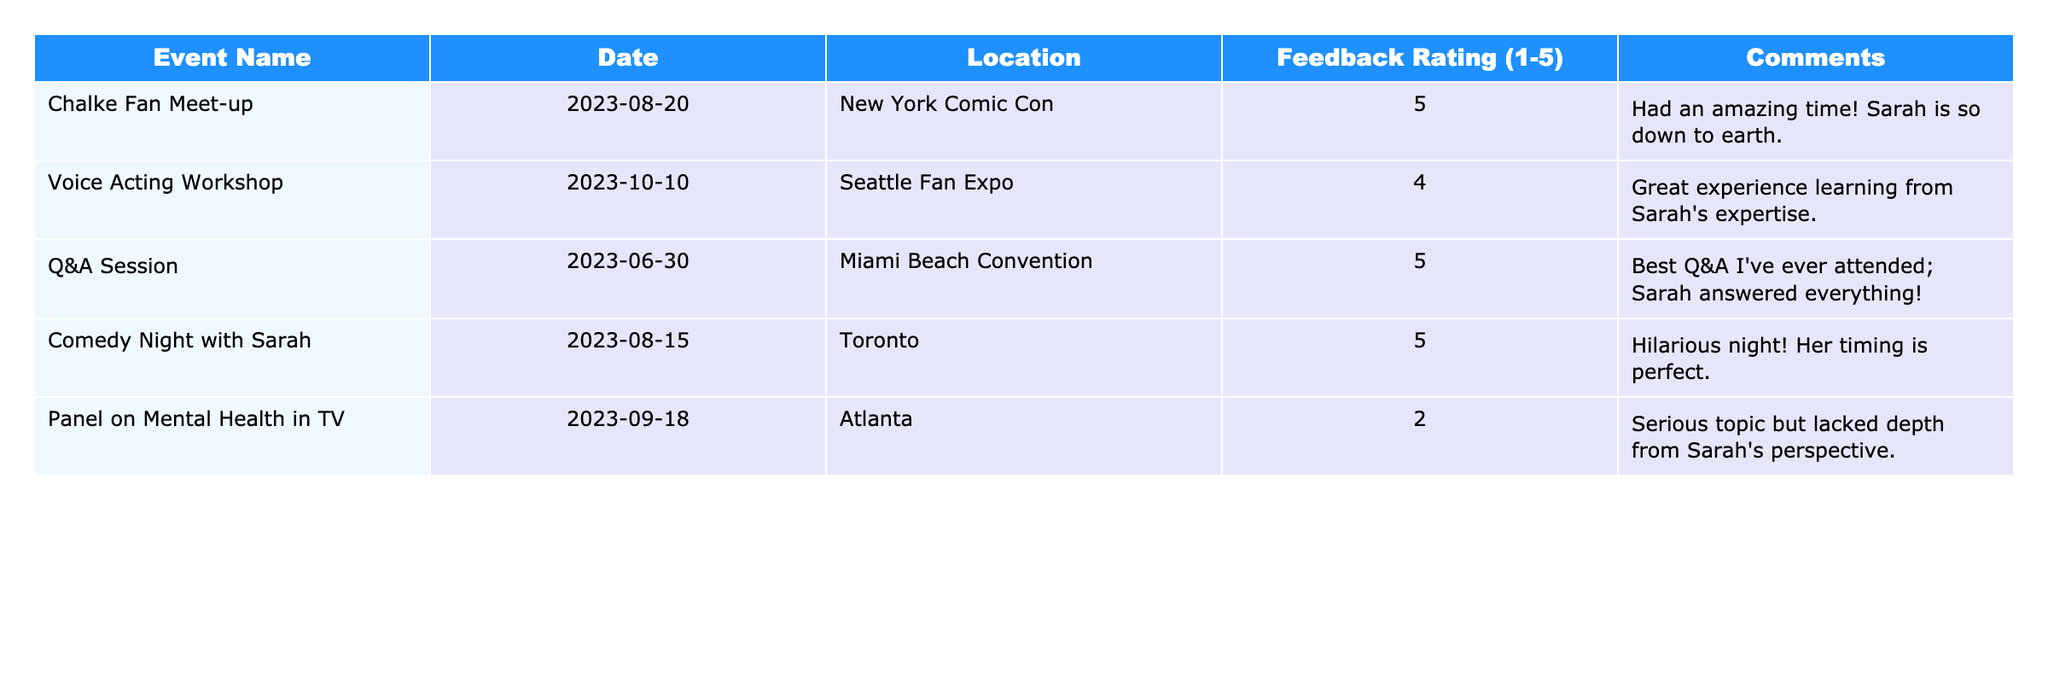What was the feedback rating for the "Comedy Night with Sarah"? Referring to the table, the feedback rating for the event "Comedy Night with Sarah" is found in the corresponding row, which shows a rating of 5.
Answer: 5 How many events received a feedback rating of 5? By examining the ratings in the table, there are four events listed with a feedback rating of 5: "Chalke Fan Meet-up", "Q&A Session", "Comedy Night with Sarah", and "Voice Acting Workshop".
Answer: 4 What is the average feedback rating across all events? To find the average, sum the ratings: 5 + 4 + 5 + 5 + 2 = 21. There are 5 events, so the average is 21/5 = 4.2.
Answer: 4.2 Did the "Panel on Mental Health in TV" receive a higher rating than 3? Checking the rating for this event, it shows a feedback rating of 2, which is lower than 3. Therefore, the answer is no.
Answer: No Which event had the lowest feedback rating and what was the rating? Looking at the ratings, the event with the lowest rating is "Panel on Mental Health in TV" with a score of 2.
Answer: "Panel on Mental Health in TV", 2 How many events were held in Atlanta? By reviewing the location column, it shows that there is one event held in Atlanta, which is "Panel on Mental Health in TV".
Answer: 1 What percentage of events received a rating of 5? There are 4 events with a rating of 5 out of 5 total events. The percentage is (4/5) * 100 = 80%.
Answer: 80% Which event had the most positive feedback based on comments? Analyzing the comments, the events "Q&A Session", "Comedy Night with Sarah", and "Chalke Fan Meet-up" all received very positive remarks, but "Comedy Night with Sarah" also received the highest possible rating of 5.
Answer: "Comedy Night with Sarah" If we were to ignore the event with the lowest feedback rating, what would the new average rating be? Ignoring the "Panel on Mental Health in TV" with a rating of 2, the new sum of ratings (5 + 4 + 5 + 5) = 19 over 4 events results in an average of 19/4 = 4.75.
Answer: 4.75 Is the "Voice Acting Workshop" the only event that received a rating of 4? By observing the ratings, it is evident that "Voice Acting Workshop" is the only event listed with a rating of 4.
Answer: Yes 